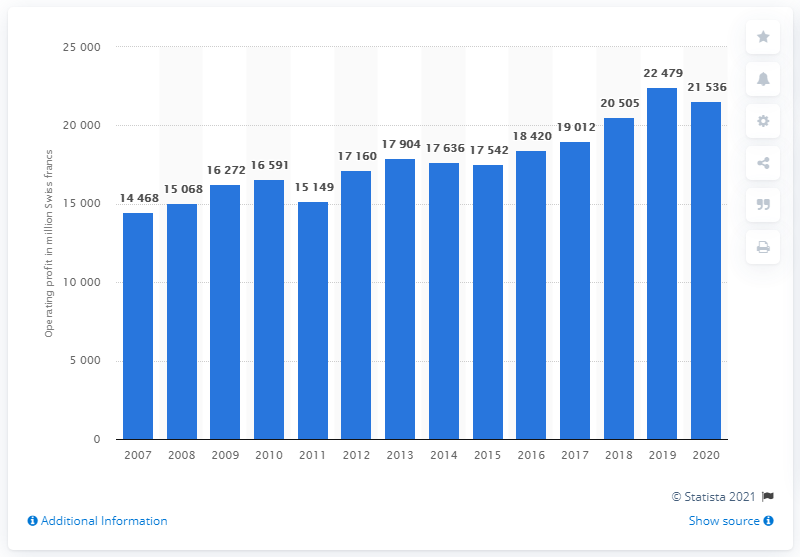List a handful of essential elements in this visual. The operating profit of Roche in 2007 was 14,468. The core operating profit of Roche in 2020 was 21,536. 